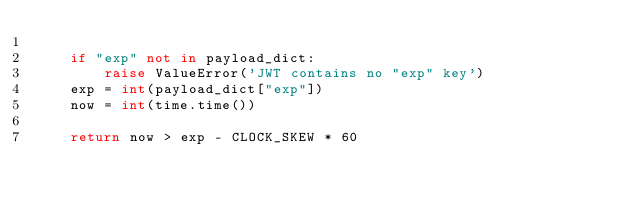<code> <loc_0><loc_0><loc_500><loc_500><_Python_>
    if "exp" not in payload_dict:
        raise ValueError('JWT contains no "exp" key')
    exp = int(payload_dict["exp"])
    now = int(time.time())

    return now > exp - CLOCK_SKEW * 60
</code> 